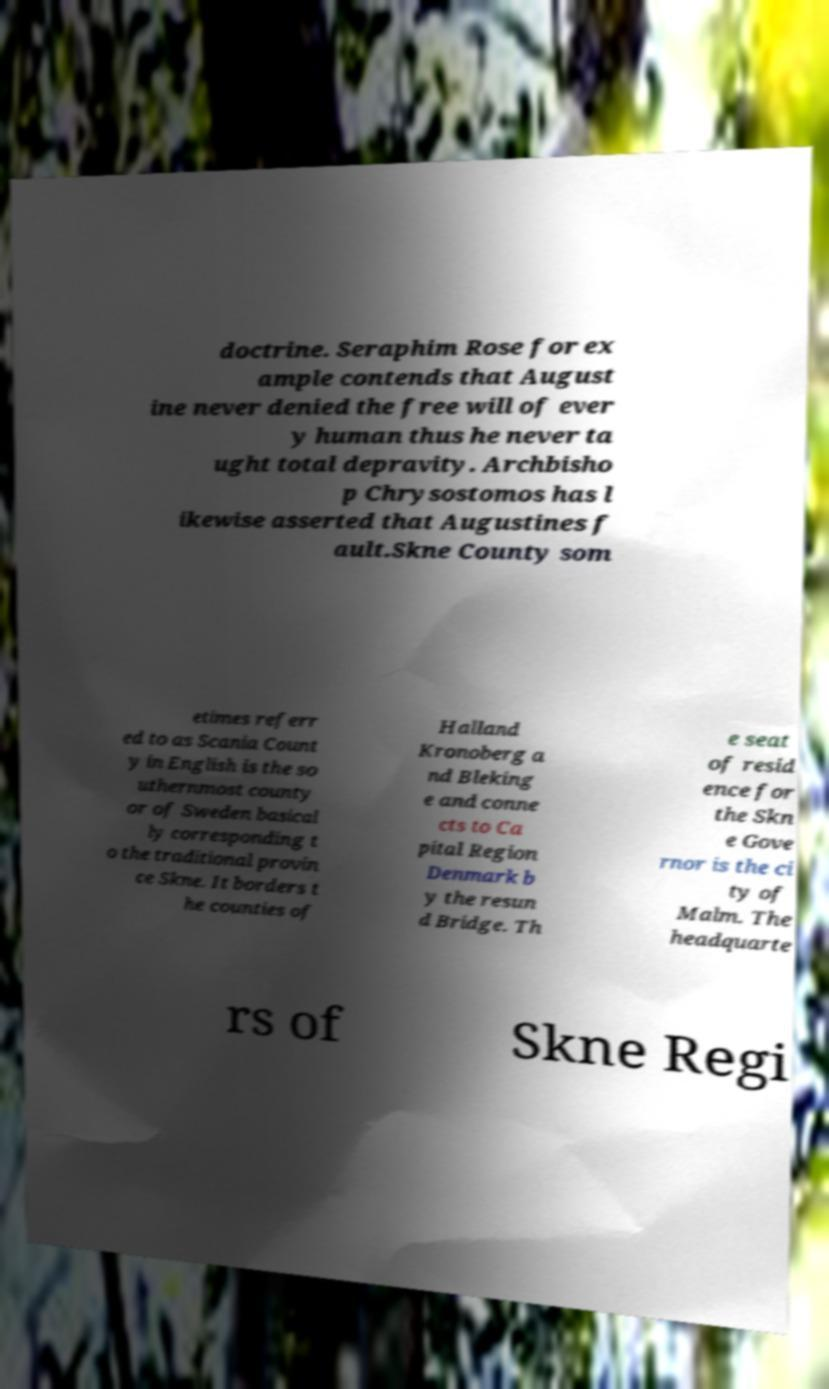Could you extract and type out the text from this image? doctrine. Seraphim Rose for ex ample contends that August ine never denied the free will of ever y human thus he never ta ught total depravity. Archbisho p Chrysostomos has l ikewise asserted that Augustines f ault.Skne County som etimes referr ed to as Scania Count y in English is the so uthernmost county or of Sweden basical ly corresponding t o the traditional provin ce Skne. It borders t he counties of Halland Kronoberg a nd Bleking e and conne cts to Ca pital Region Denmark b y the resun d Bridge. Th e seat of resid ence for the Skn e Gove rnor is the ci ty of Malm. The headquarte rs of Skne Regi 